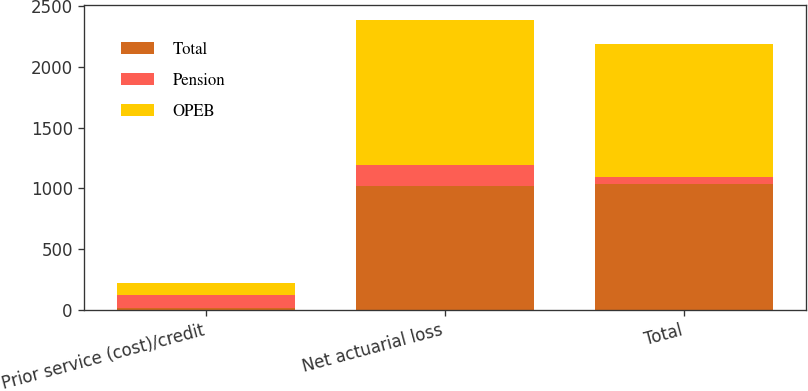<chart> <loc_0><loc_0><loc_500><loc_500><stacked_bar_chart><ecel><fcel>Prior service (cost)/credit<fcel>Net actuarial loss<fcel>Total<nl><fcel>Total<fcel>12<fcel>1023<fcel>1035<nl><fcel>Pension<fcel>111<fcel>172<fcel>61<nl><fcel>OPEB<fcel>99<fcel>1195<fcel>1096<nl></chart> 